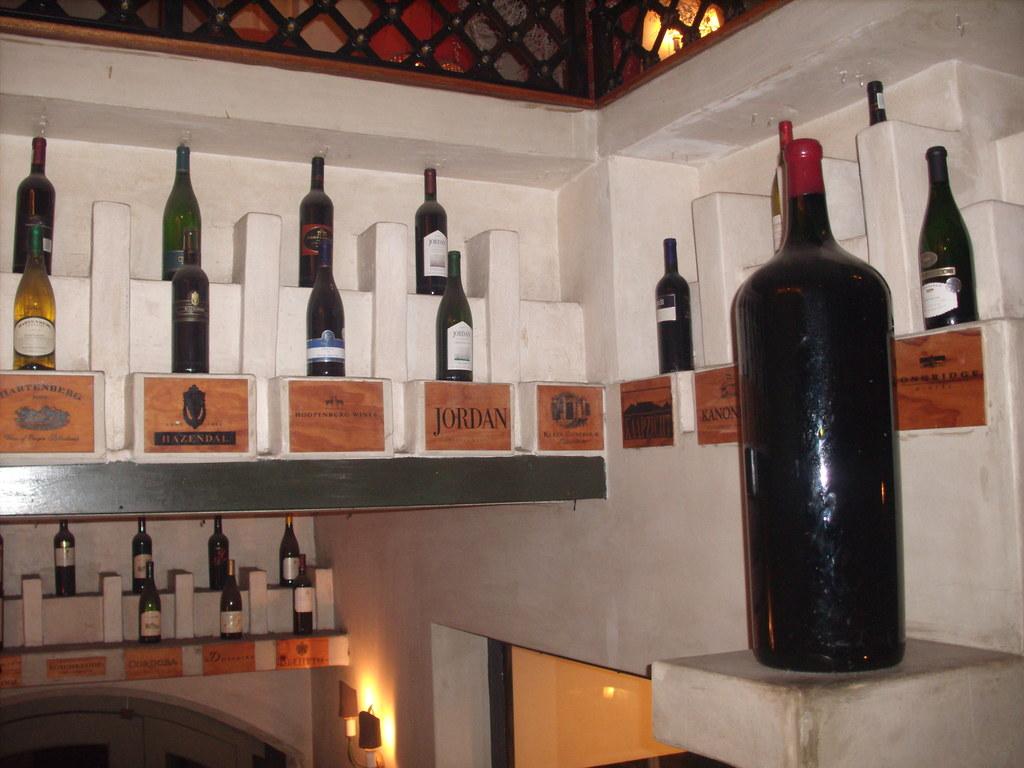What wine brands are there?
Provide a succinct answer. Jordan. 